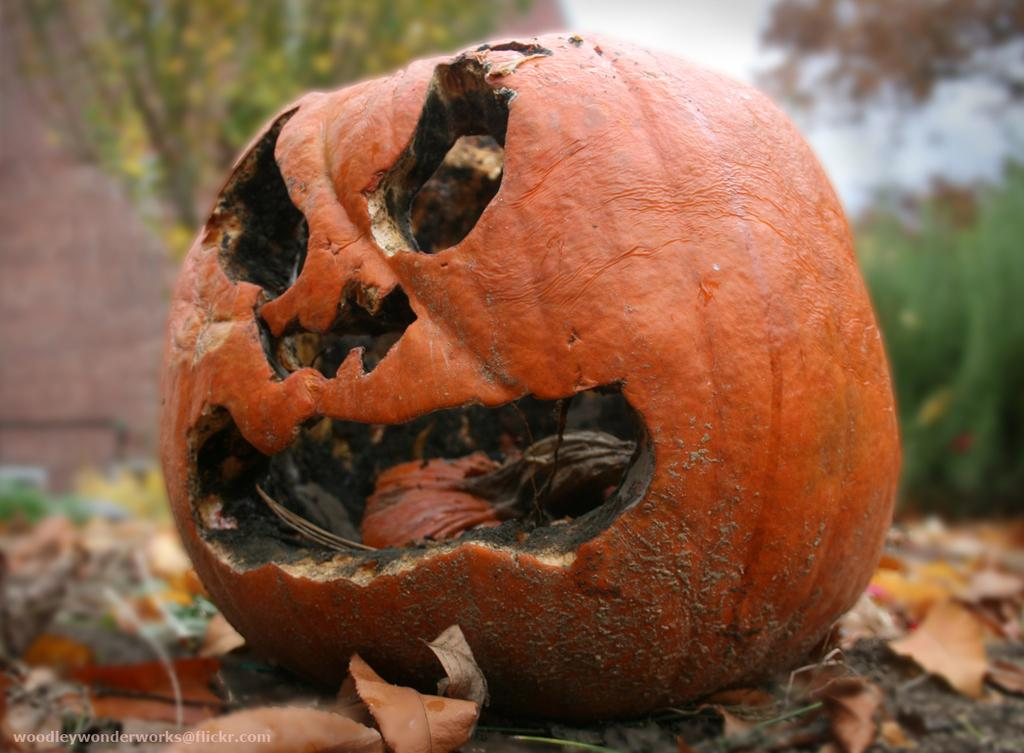What is the main object in the center of the image? There is a pumpkin in the center of the image. What type of vegetation can be seen at the bottom of the image? Dry leaves are present at the bottom of the image. What can be seen in the background of the image? There are trees in the background of the image. What type of oven can be seen in the image? There is no oven present in the image. 